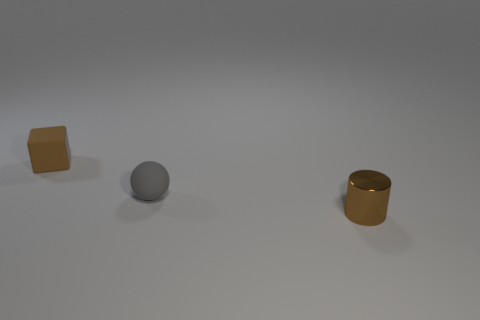Is there anything else that has the same material as the tiny cylinder?
Ensure brevity in your answer.  No. What number of things are either brown things that are to the right of the brown matte thing or small matte things to the left of the tiny ball?
Your answer should be very brief. 2. There is a tiny shiny thing; is its shape the same as the brown thing to the left of the brown metal object?
Keep it short and to the point. No. There is a thing in front of the matte thing that is right of the small brown object that is behind the small cylinder; what shape is it?
Give a very brief answer. Cylinder. What number of other objects are there of the same material as the small cube?
Make the answer very short. 1. How many things are either brown shiny things to the right of the tiny rubber sphere or tiny brown rubber objects?
Offer a terse response. 2. The brown thing behind the tiny brown object in front of the cube is what shape?
Your answer should be very brief. Cube. Does the small brown object that is to the left of the brown cylinder have the same shape as the shiny thing?
Offer a very short reply. No. What is the color of the object that is behind the gray matte sphere?
Make the answer very short. Brown. How many balls are either gray rubber things or matte objects?
Ensure brevity in your answer.  1. 